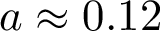Convert formula to latex. <formula><loc_0><loc_0><loc_500><loc_500>a \approx 0 . 1 2</formula> 